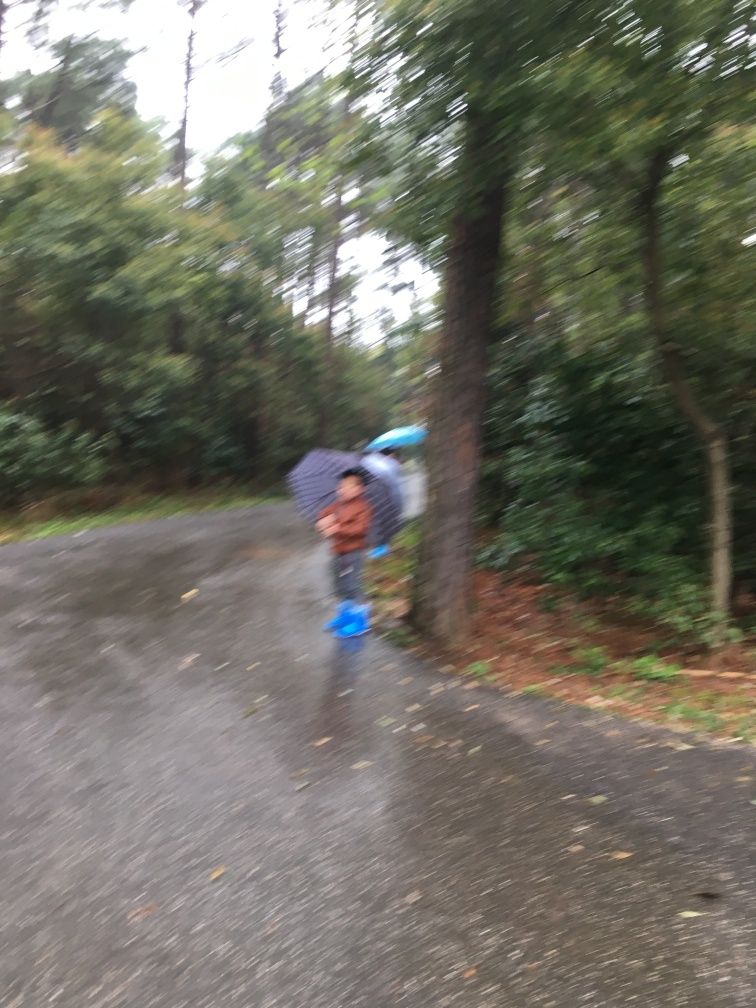Are there any quality issues with this image? Yes, the image appears to be blurry, which may be caused by camera movement or a slow shutter speed in low light conditions. This affects the clarity and sharpness of the subjects in the photo. Furthermore, the composition could be improved for better visual appeal. 